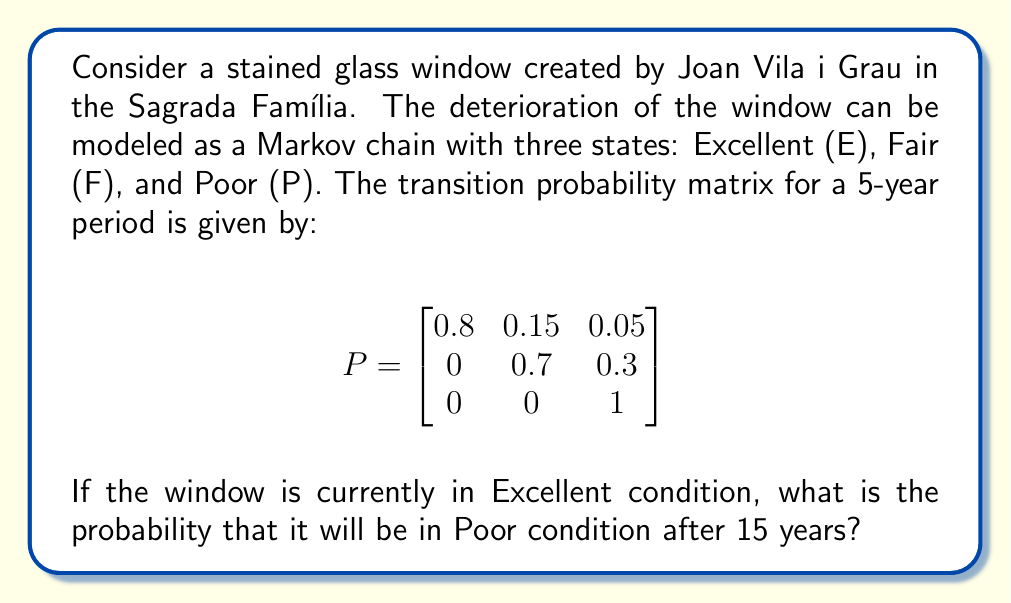Help me with this question. To solve this problem, we need to follow these steps:

1) First, we need to calculate the transition matrix for a 15-year period. Since our given matrix is for a 5-year period, we need to raise it to the power of 3.

2) Let's call our 15-year transition matrix $P^{(3)}$. We can calculate it as follows:

   $P^{(3)} = P^3 = P \times P \times P$

3) Using matrix multiplication:

   $$P^2 = \begin{bmatrix}
   0.8 & 0.15 & 0.05 \\
   0 & 0.7 & 0.3 \\
   0 & 0 & 1
   \end{bmatrix} \times 
   \begin{bmatrix}
   0.8 & 0.15 & 0.05 \\
   0 & 0.7 & 0.3 \\
   0 & 0 & 1
   \end{bmatrix} = 
   \begin{bmatrix}
   0.64 & 0.225 & 0.135 \\
   0 & 0.49 & 0.51 \\
   0 & 0 & 1
   \end{bmatrix}$$

4) Now, we multiply $P^2$ by $P$ again:

   $$P^{(3)} = P^3 = P^2 \times P = 
   \begin{bmatrix}
   0.64 & 0.225 & 0.135 \\
   0 & 0.49 & 0.51 \\
   0 & 0 & 1
   \end{bmatrix} \times
   \begin{bmatrix}
   0.8 & 0.15 & 0.05 \\
   0 & 0.7 & 0.3 \\
   0 & 0 & 1
   \end{bmatrix} = 
   \begin{bmatrix}
   0.512 & 0.2475 & 0.2405 \\
   0 & 0.343 & 0.657 \\
   0 & 0 & 1
   \end{bmatrix}$$

5) The probability we're looking for is the entry in the first row, third column of $P^{(3)}$, as we start in the Excellent state (first row) and want to end in the Poor state (third column).

Therefore, the probability that the window will be in Poor condition after 15 years, given that it starts in Excellent condition, is 0.2405 or approximately 24.05%.
Answer: 0.2405 